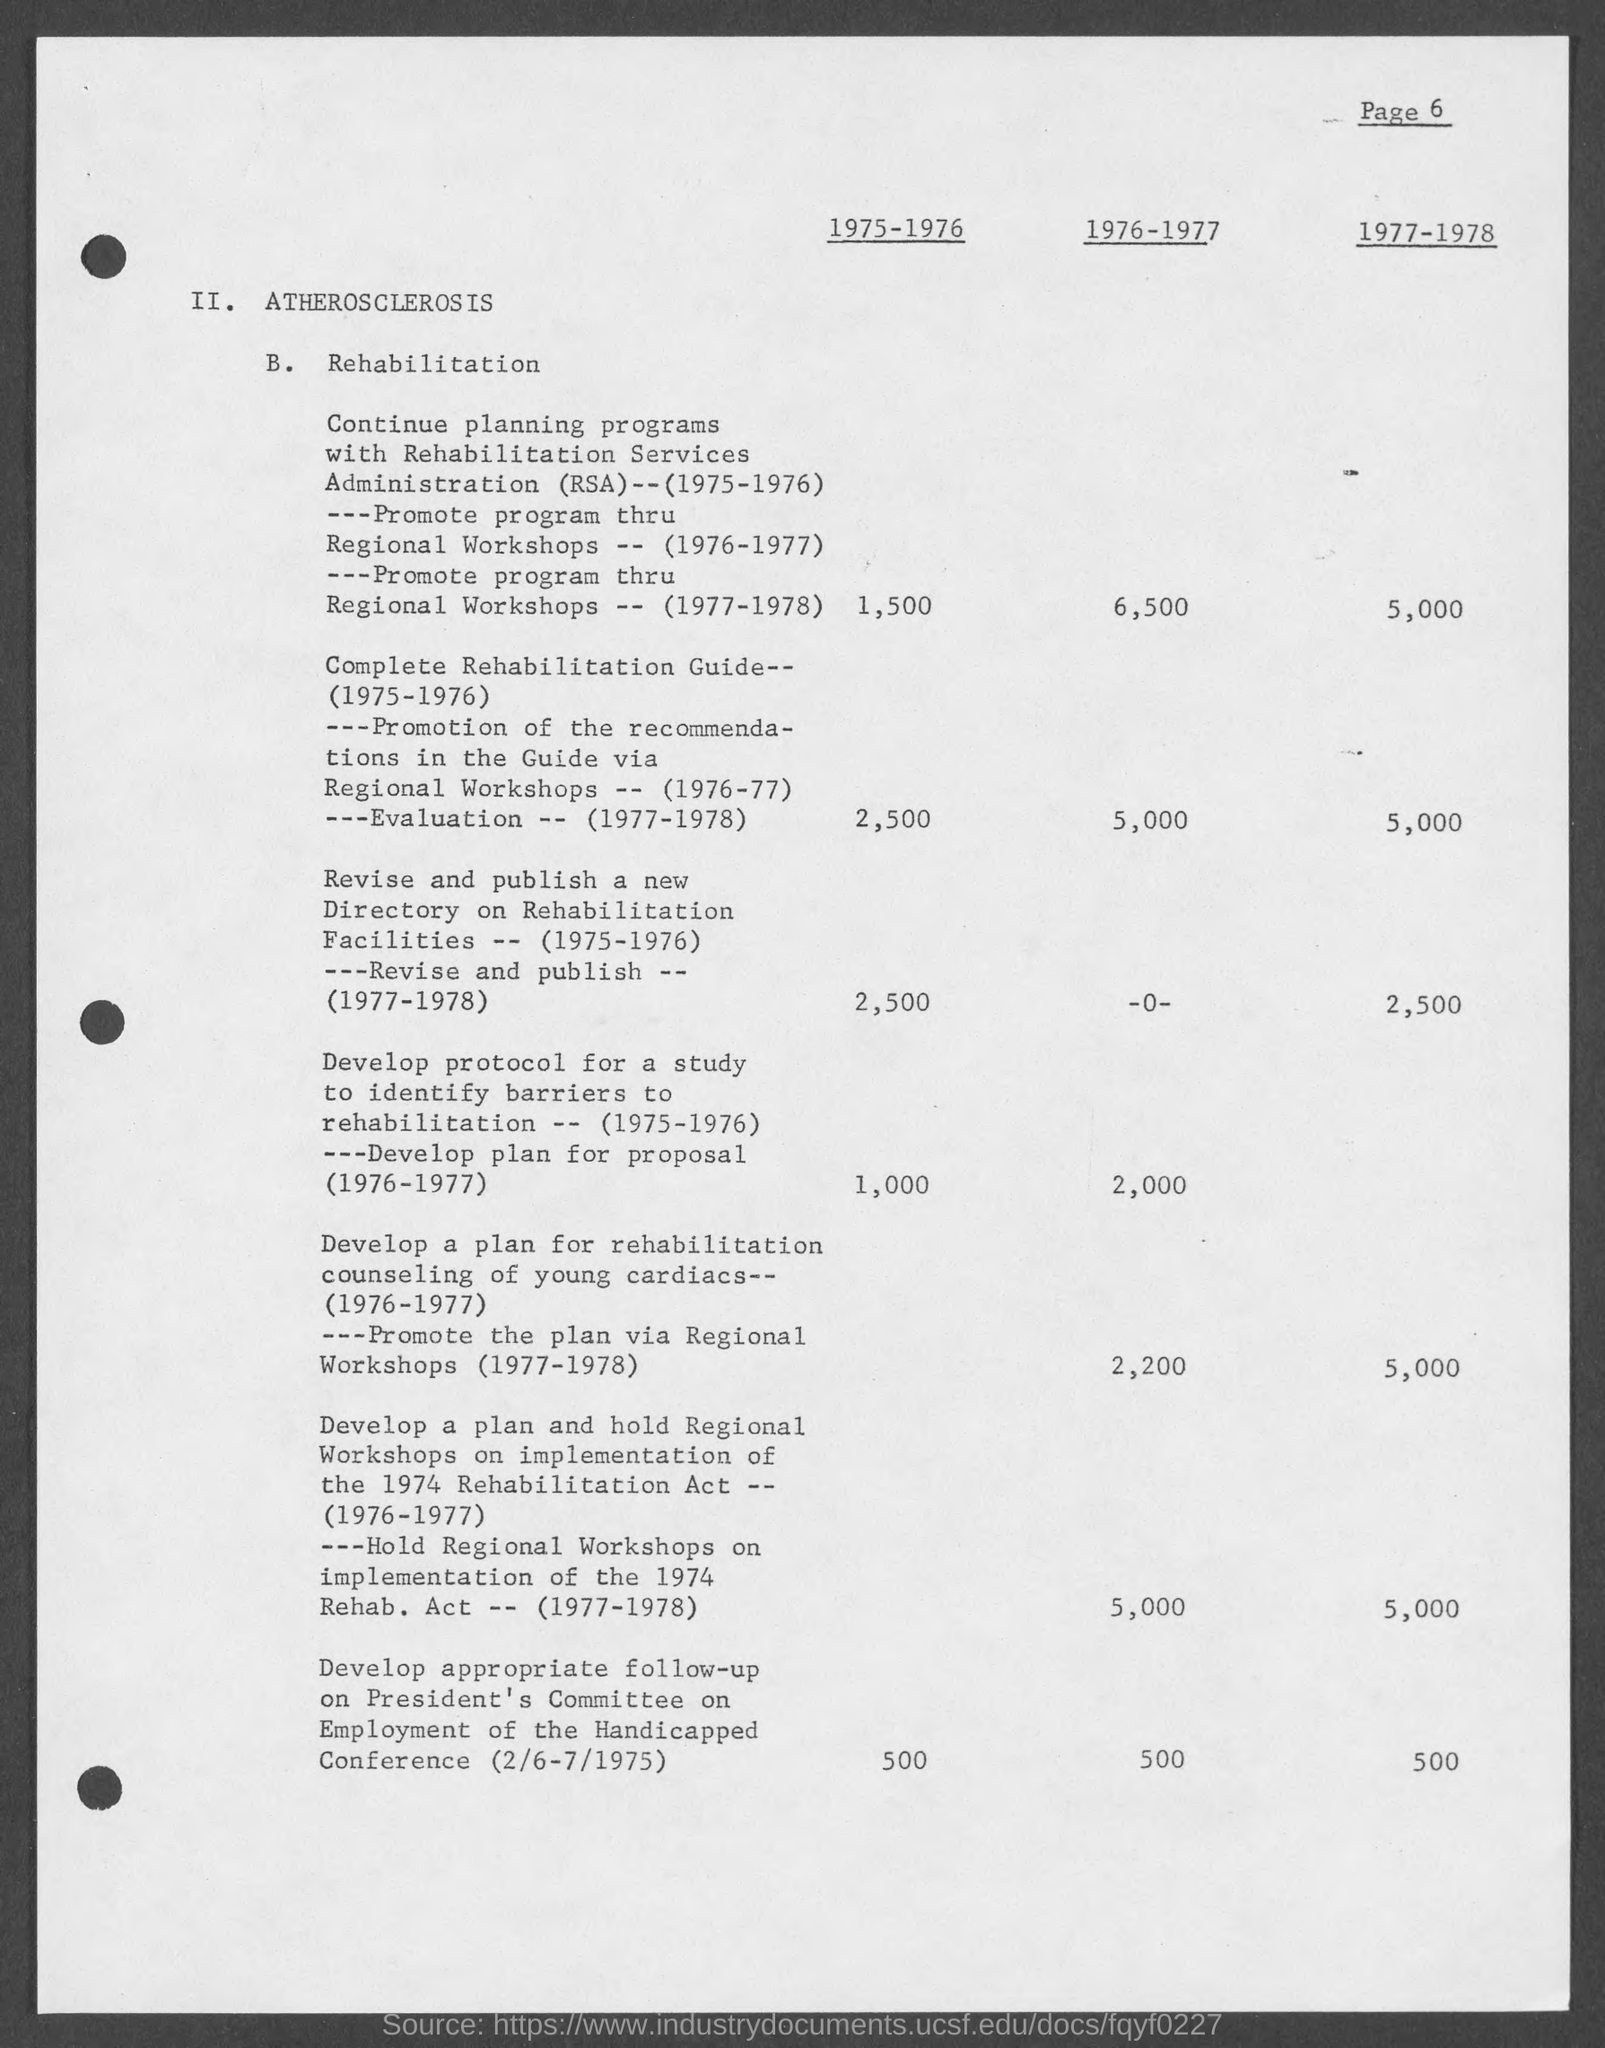Point out several critical features in this image. This page is currently on page 6. Point B. refers to rehabilitation. 